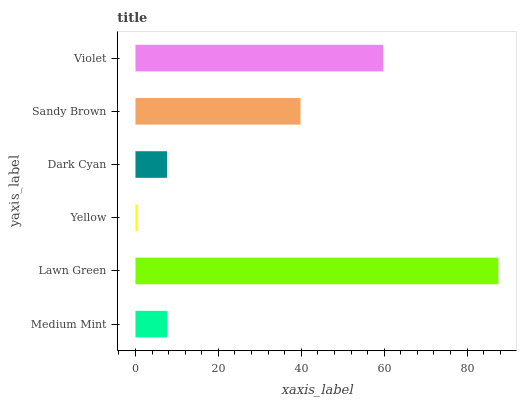Is Yellow the minimum?
Answer yes or no. Yes. Is Lawn Green the maximum?
Answer yes or no. Yes. Is Lawn Green the minimum?
Answer yes or no. No. Is Yellow the maximum?
Answer yes or no. No. Is Lawn Green greater than Yellow?
Answer yes or no. Yes. Is Yellow less than Lawn Green?
Answer yes or no. Yes. Is Yellow greater than Lawn Green?
Answer yes or no. No. Is Lawn Green less than Yellow?
Answer yes or no. No. Is Sandy Brown the high median?
Answer yes or no. Yes. Is Medium Mint the low median?
Answer yes or no. Yes. Is Dark Cyan the high median?
Answer yes or no. No. Is Sandy Brown the low median?
Answer yes or no. No. 